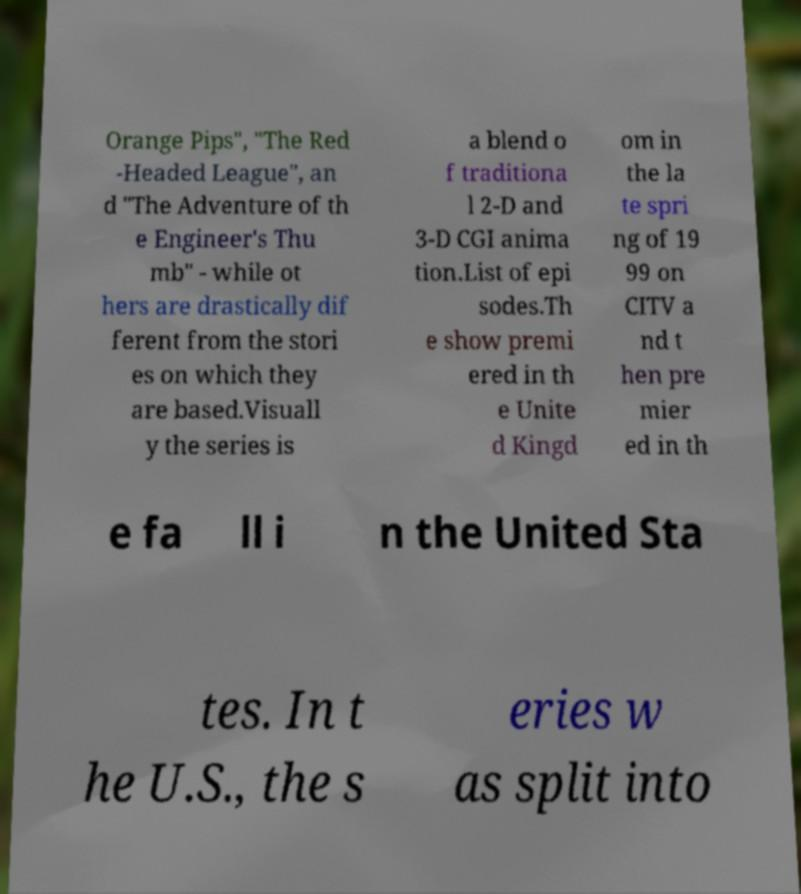Please read and relay the text visible in this image. What does it say? Orange Pips", "The Red -Headed League", an d "The Adventure of th e Engineer's Thu mb" - while ot hers are drastically dif ferent from the stori es on which they are based.Visuall y the series is a blend o f traditiona l 2-D and 3-D CGI anima tion.List of epi sodes.Th e show premi ered in th e Unite d Kingd om in the la te spri ng of 19 99 on CITV a nd t hen pre mier ed in th e fa ll i n the United Sta tes. In t he U.S., the s eries w as split into 